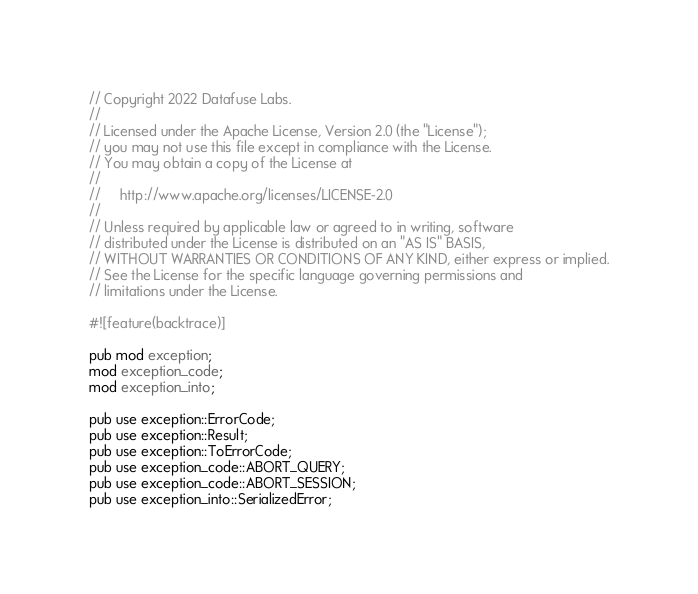Convert code to text. <code><loc_0><loc_0><loc_500><loc_500><_Rust_>// Copyright 2022 Datafuse Labs.
//
// Licensed under the Apache License, Version 2.0 (the "License");
// you may not use this file except in compliance with the License.
// You may obtain a copy of the License at
//
//     http://www.apache.org/licenses/LICENSE-2.0
//
// Unless required by applicable law or agreed to in writing, software
// distributed under the License is distributed on an "AS IS" BASIS,
// WITHOUT WARRANTIES OR CONDITIONS OF ANY KIND, either express or implied.
// See the License for the specific language governing permissions and
// limitations under the License.

#![feature(backtrace)]

pub mod exception;
mod exception_code;
mod exception_into;

pub use exception::ErrorCode;
pub use exception::Result;
pub use exception::ToErrorCode;
pub use exception_code::ABORT_QUERY;
pub use exception_code::ABORT_SESSION;
pub use exception_into::SerializedError;
</code> 